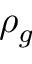Convert formula to latex. <formula><loc_0><loc_0><loc_500><loc_500>\rho _ { g }</formula> 